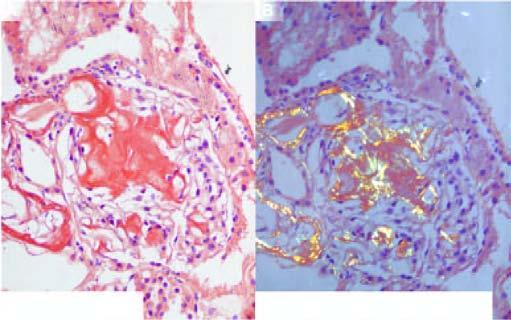what show apple-green birefringence?
Answer the question using a single word or phrase. Congophilic areas 